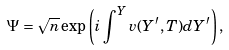<formula> <loc_0><loc_0><loc_500><loc_500>\Psi = \sqrt { n } \exp \left ( i \int ^ { Y } v ( Y ^ { \prime } , T ) d Y ^ { \prime } \right ) ,</formula> 